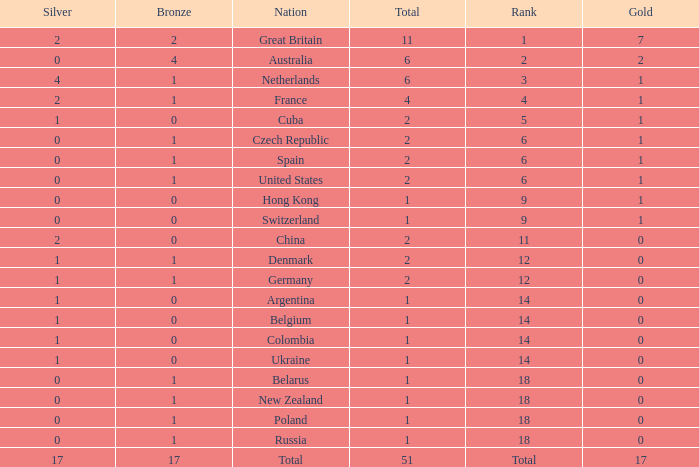Tell me the rank for bronze less than 17 and gold less than 1 11.0. 